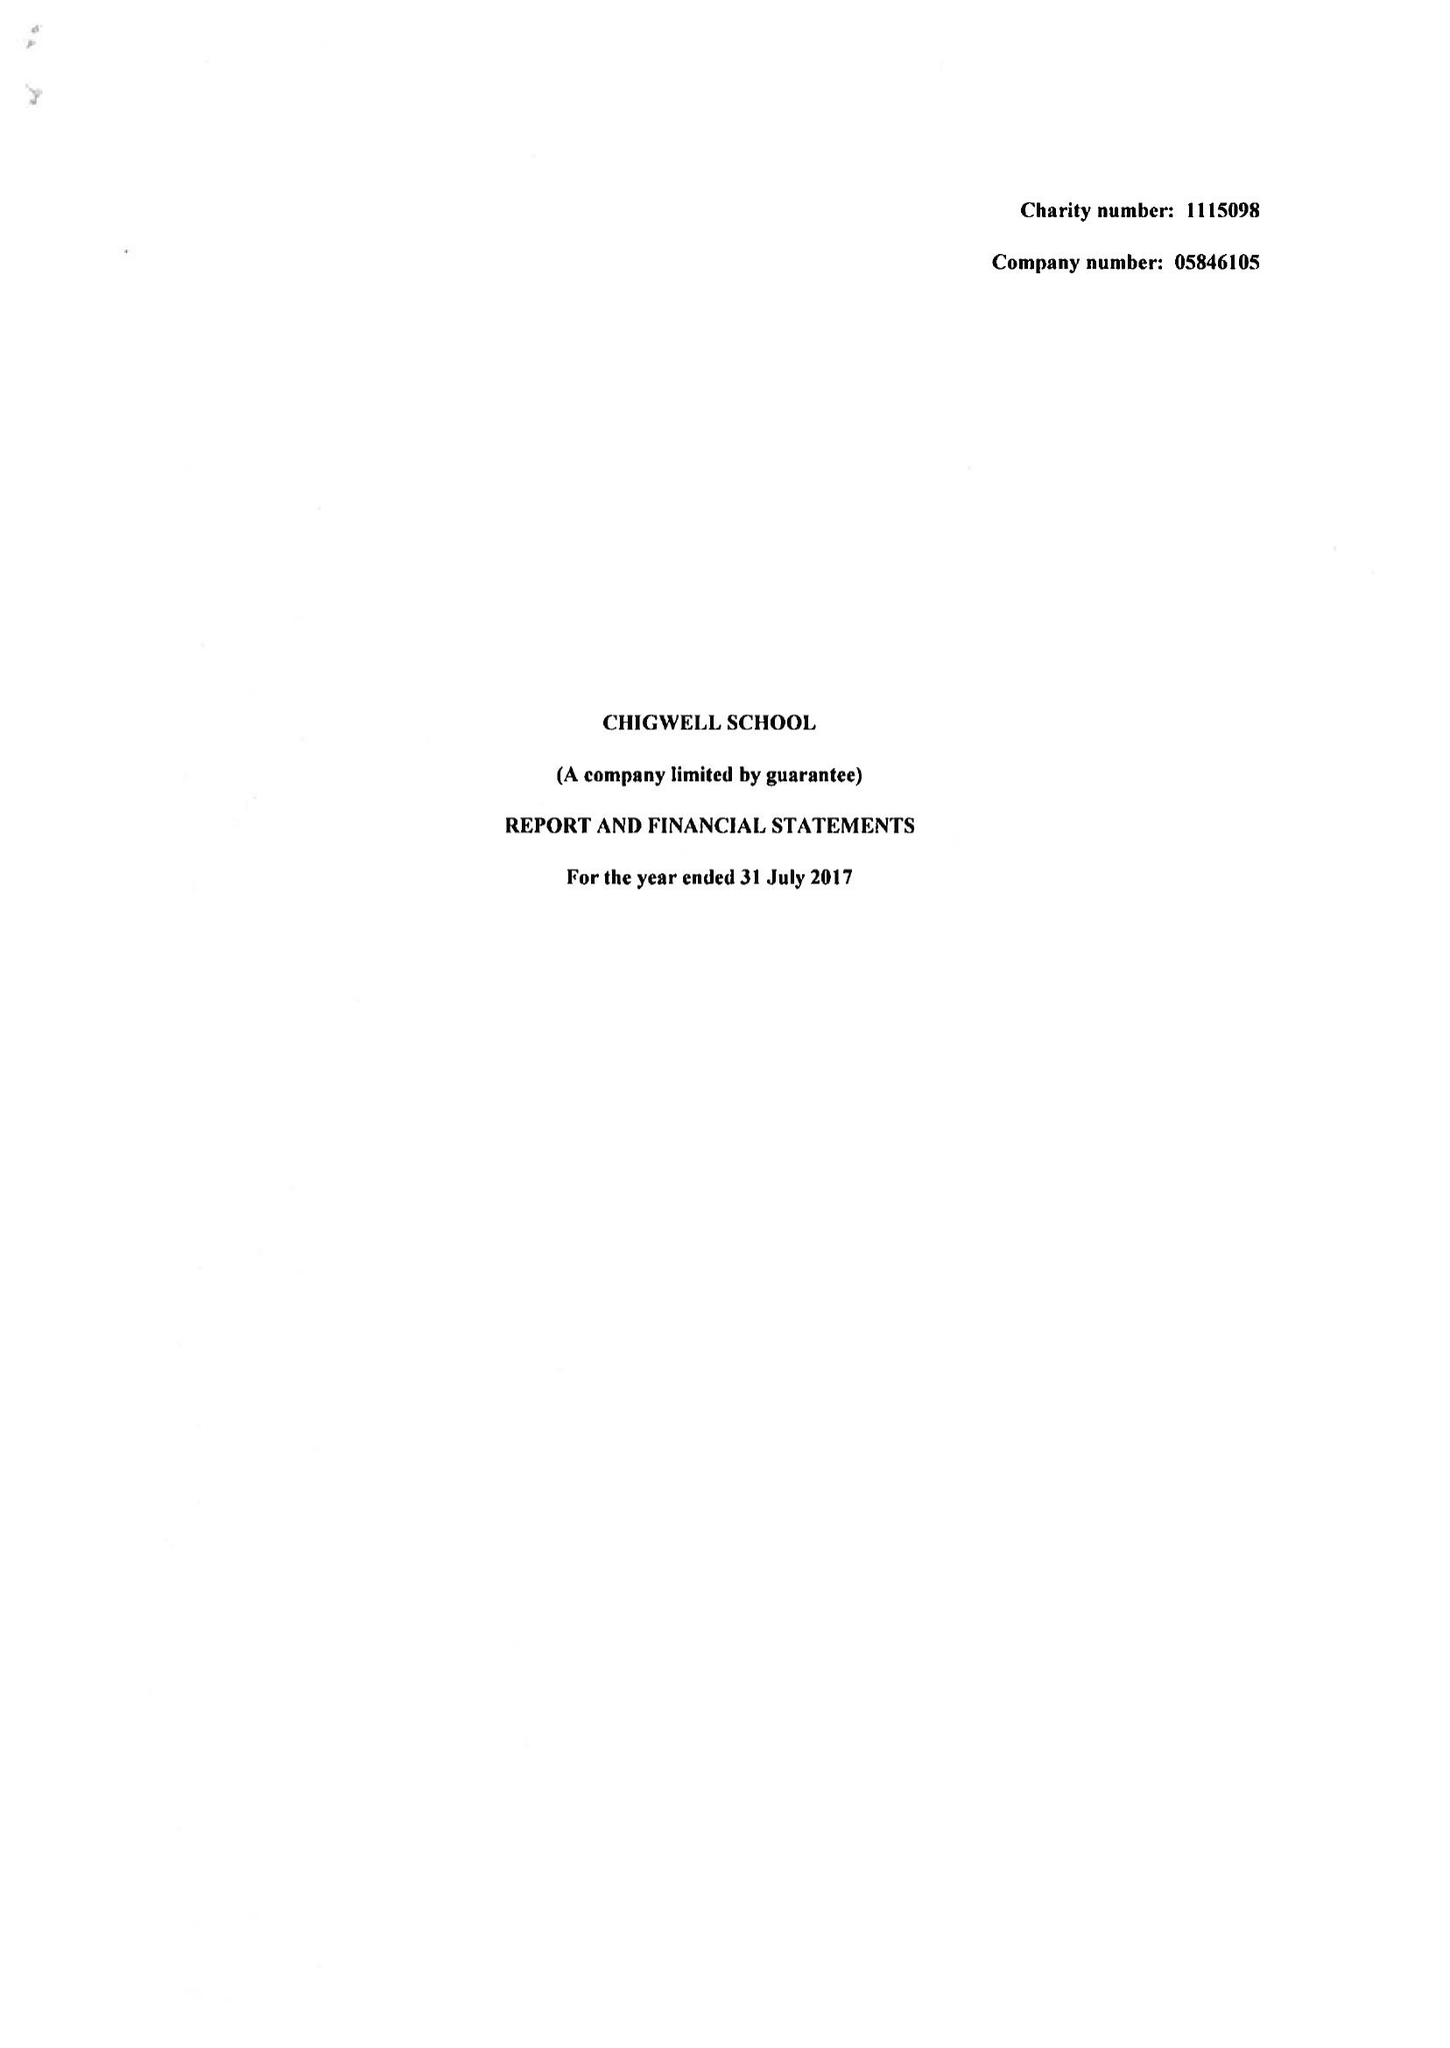What is the value for the charity_number?
Answer the question using a single word or phrase. 1115098 